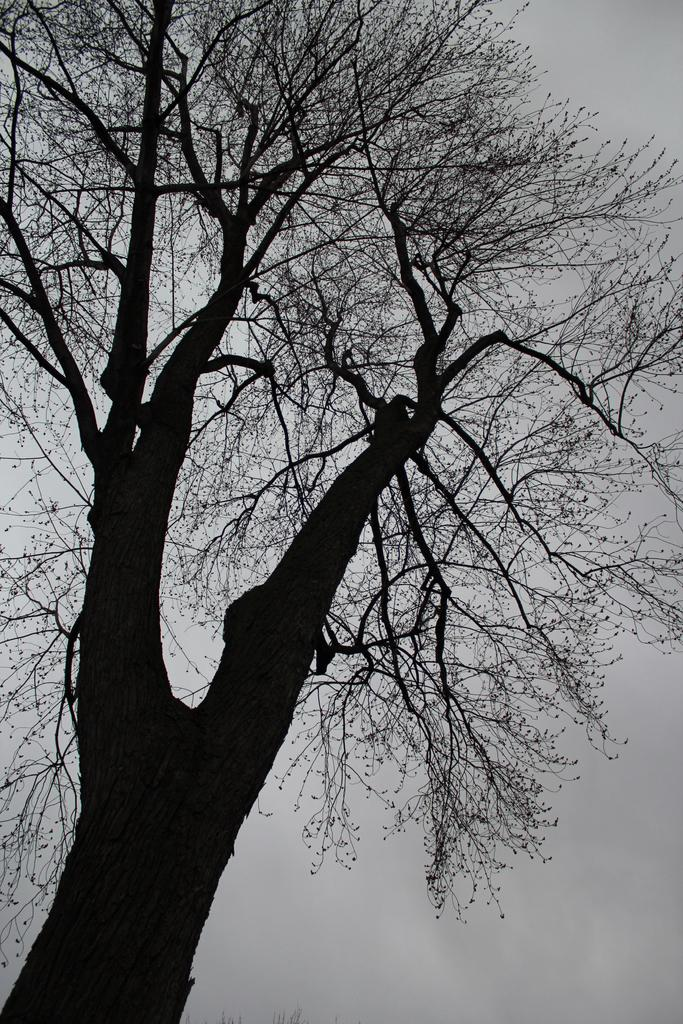What type of image is present in the picture? The image contains a black and white picture. What is the main subject of the black and white picture? The picture depicts a tree. What part of the natural environment is visible in the picture? The sky is visible in the picture. How does the stem of the tree react during the earthquake in the image? There is no earthquake present in the image, and therefore no such reaction can be observed. 